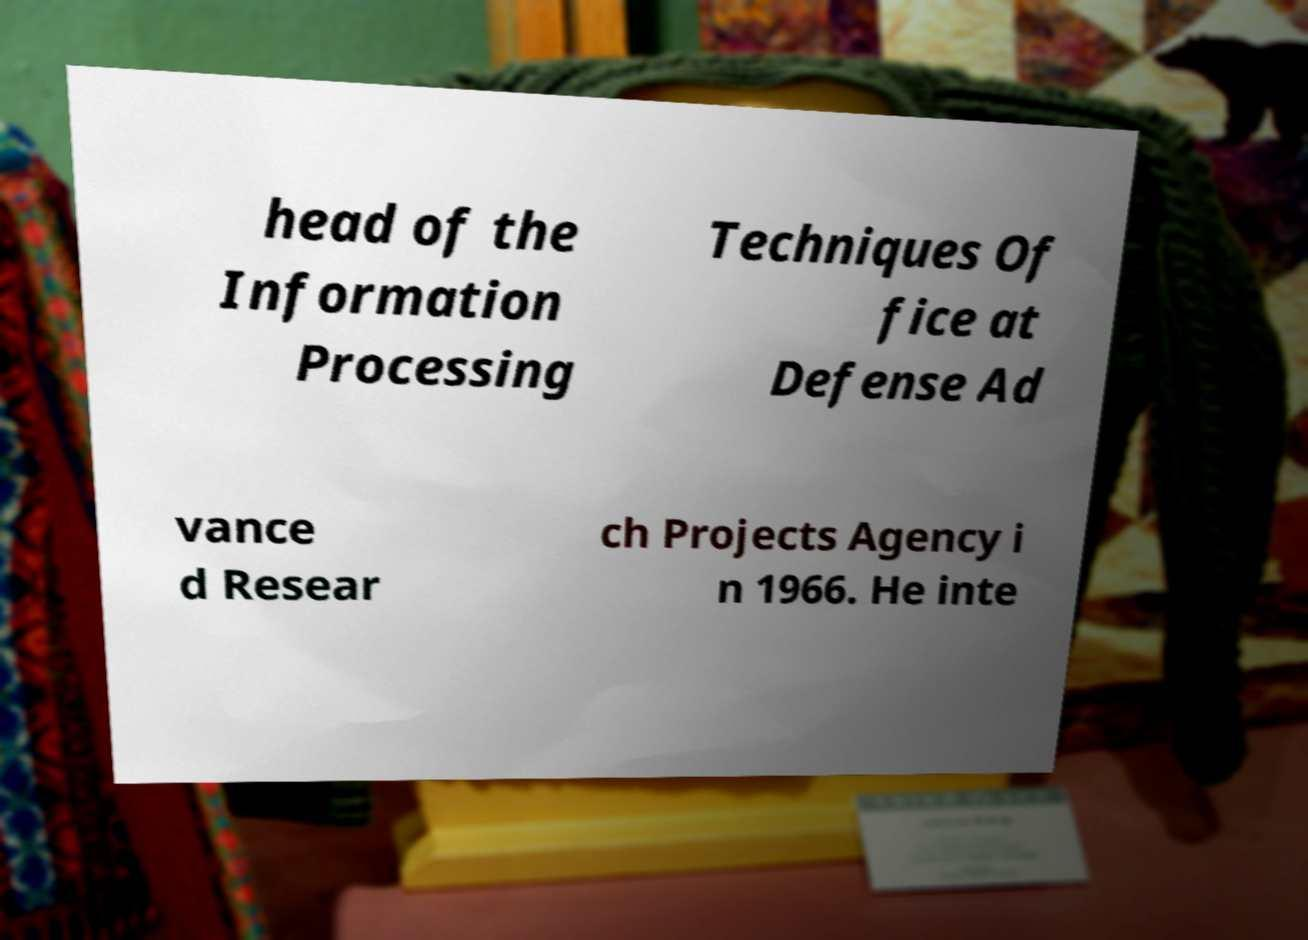Could you assist in decoding the text presented in this image and type it out clearly? head of the Information Processing Techniques Of fice at Defense Ad vance d Resear ch Projects Agency i n 1966. He inte 